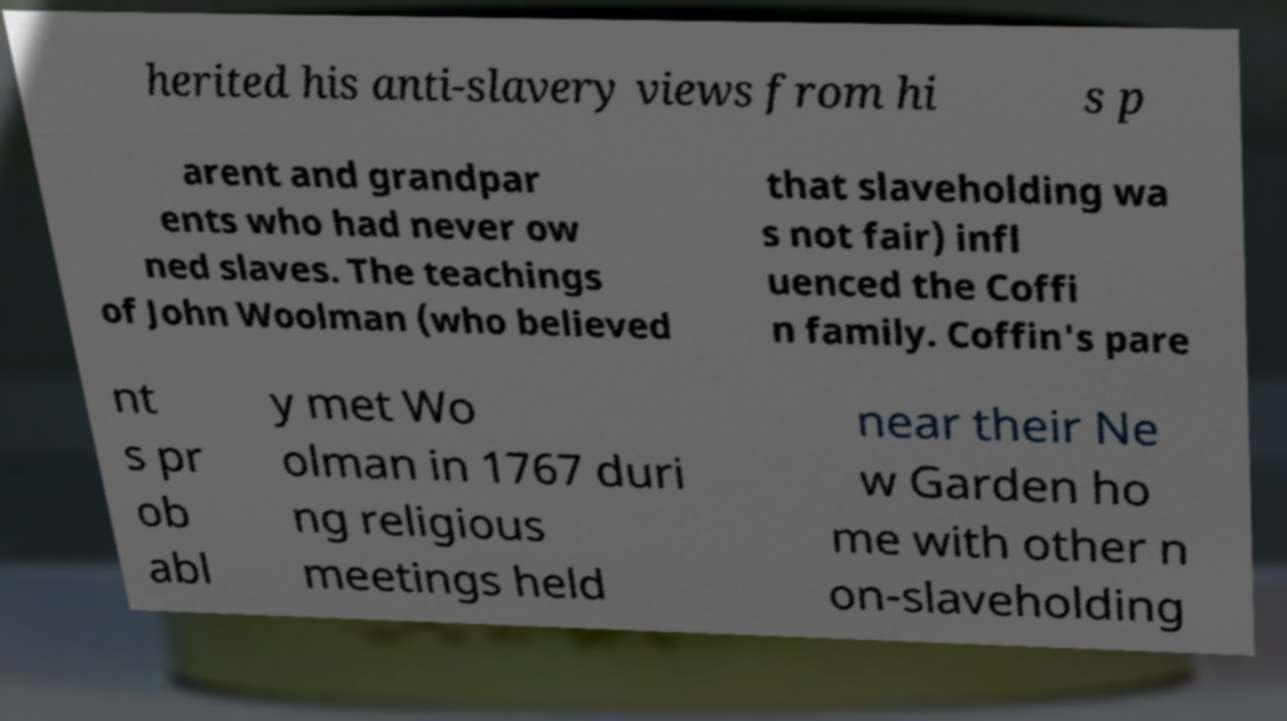Please read and relay the text visible in this image. What does it say? herited his anti-slavery views from hi s p arent and grandpar ents who had never ow ned slaves. The teachings of John Woolman (who believed that slaveholding wa s not fair) infl uenced the Coffi n family. Coffin's pare nt s pr ob abl y met Wo olman in 1767 duri ng religious meetings held near their Ne w Garden ho me with other n on-slaveholding 